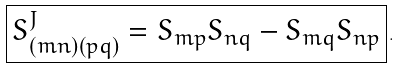Convert formula to latex. <formula><loc_0><loc_0><loc_500><loc_500>\boxed { S ^ { J } _ { ( m n ) ( p q ) } = S _ { m p } S _ { n q } - S _ { m q } S _ { n p } } \, .</formula> 